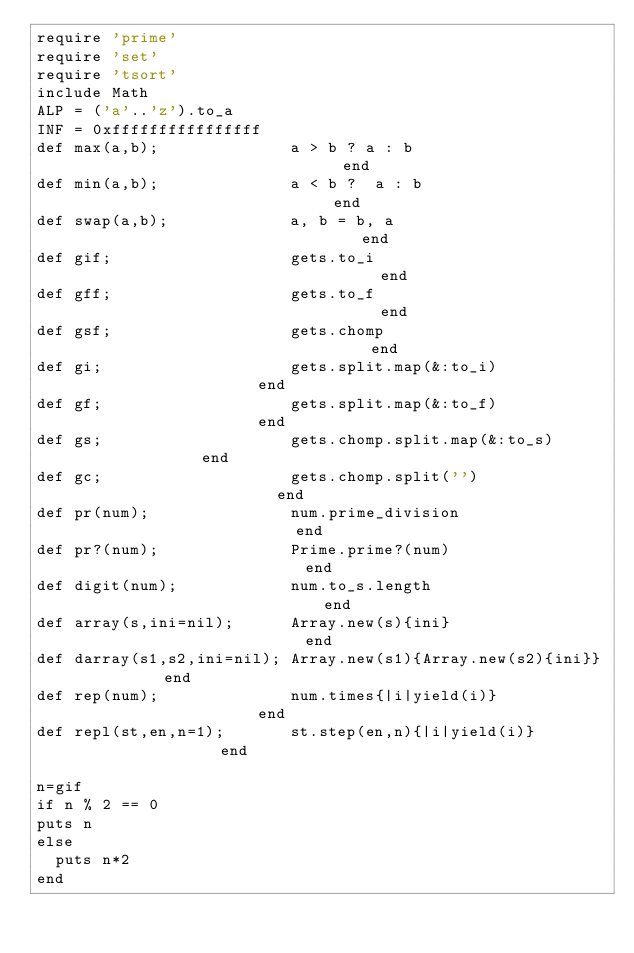Convert code to text. <code><loc_0><loc_0><loc_500><loc_500><_Ruby_>require 'prime'
require 'set'
require 'tsort'
include Math
ALP = ('a'..'z').to_a
INF = 0xffffffffffffffff
def max(a,b);              a > b ? a : b                              end
def min(a,b);              a < b ?  a : b                             end
def swap(a,b);             a, b = b, a                                end
def gif;                   gets.to_i                                  end
def gff;                   gets.to_f                                  end
def gsf;                   gets.chomp                                 end
def gi;                    gets.split.map(&:to_i)                     end
def gf;                    gets.split.map(&:to_f)                     end
def gs;                    gets.chomp.split.map(&:to_s)               end
def gc;                    gets.chomp.split('')                       end
def pr(num);               num.prime_division                         end
def pr?(num);              Prime.prime?(num)                          end
def digit(num);            num.to_s.length                            end
def array(s,ini=nil);      Array.new(s){ini}                          end
def darray(s1,s2,ini=nil); Array.new(s1){Array.new(s2){ini}}          end
def rep(num);              num.times{|i|yield(i)}                     end
def repl(st,en,n=1);       st.step(en,n){|i|yield(i)}                 end

n=gif
if n % 2 == 0
puts n
else
  puts n*2
end
</code> 